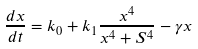<formula> <loc_0><loc_0><loc_500><loc_500>\frac { d x } { d t } = k _ { 0 } + k _ { 1 } \frac { x ^ { 4 } } { x ^ { 4 } + S ^ { 4 } } - \gamma x</formula> 